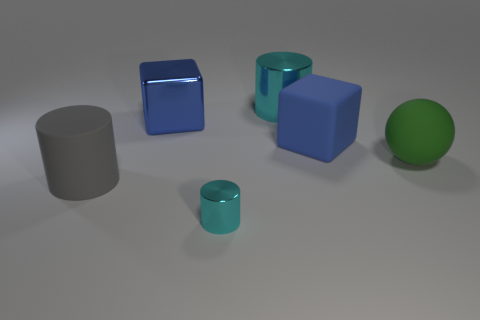What number of big things are yellow rubber blocks or gray cylinders?
Provide a short and direct response. 1. Does the matte object that is behind the big green rubber object have the same color as the shiny cube?
Offer a very short reply. Yes. Do the big cylinder that is on the right side of the tiny cyan thing and the metal cylinder in front of the green sphere have the same color?
Provide a succinct answer. Yes. Is there a large blue object that has the same material as the big gray thing?
Your answer should be compact. Yes. What number of red objects are either blocks or big things?
Offer a terse response. 0. Is the number of cyan things in front of the large cyan cylinder greater than the number of large brown rubber blocks?
Provide a short and direct response. Yes. Do the blue matte block and the gray rubber cylinder have the same size?
Your response must be concise. Yes. The block that is made of the same material as the green ball is what color?
Offer a terse response. Blue. There is a big object that is the same color as the big metallic block; what is its shape?
Offer a very short reply. Cube. Are there the same number of big blue blocks on the right side of the large gray rubber cylinder and objects that are to the left of the tiny thing?
Ensure brevity in your answer.  Yes. 